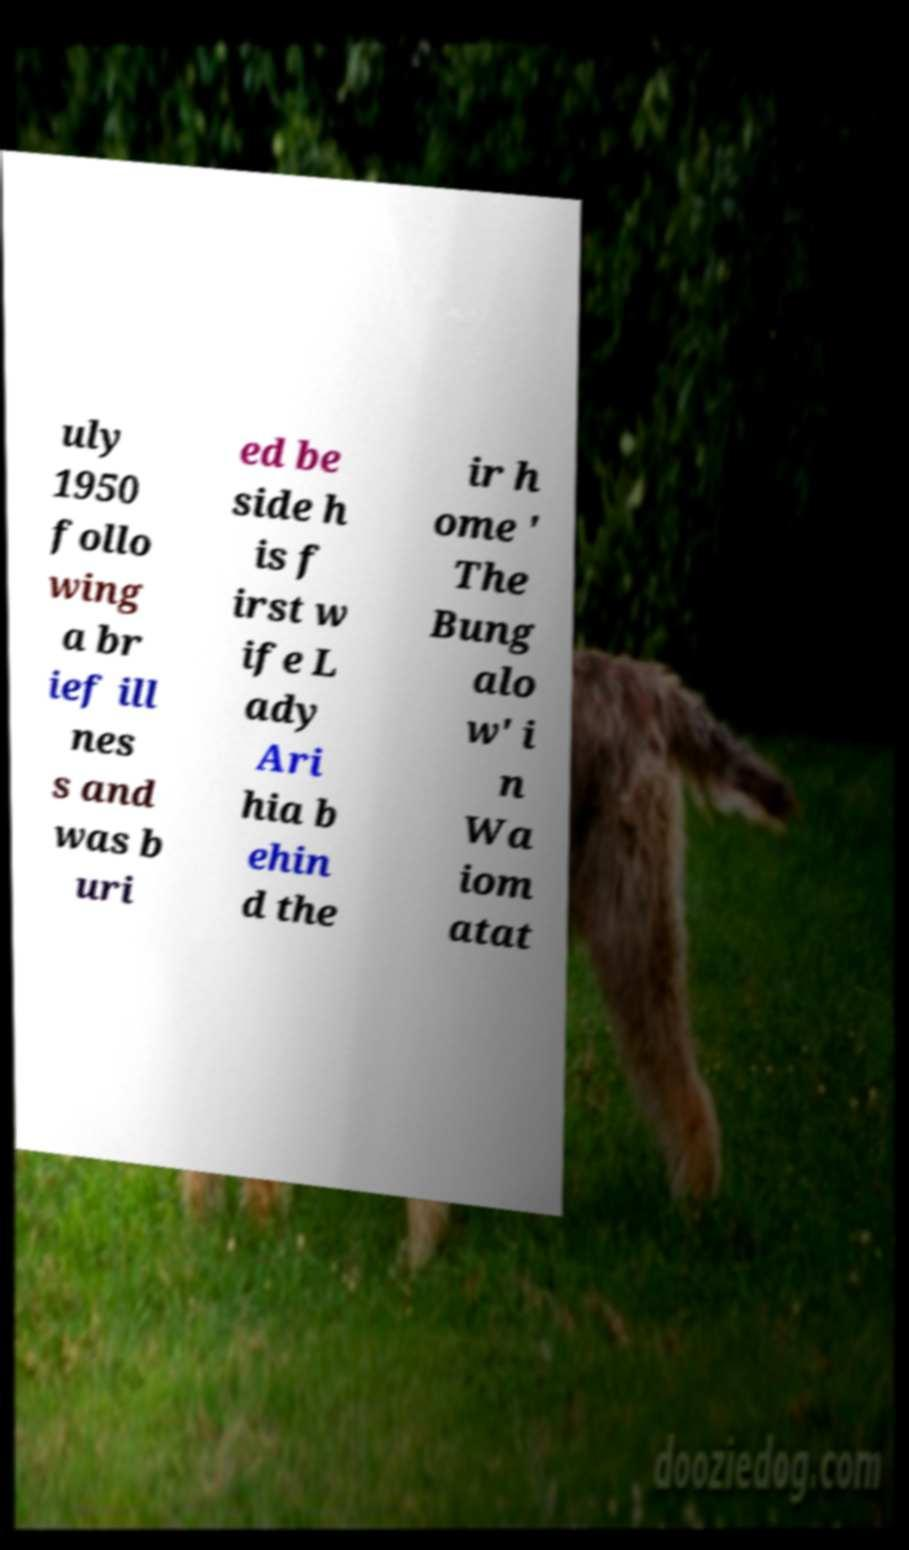I need the written content from this picture converted into text. Can you do that? uly 1950 follo wing a br ief ill nes s and was b uri ed be side h is f irst w ife L ady Ari hia b ehin d the ir h ome ' The Bung alo w' i n Wa iom atat 